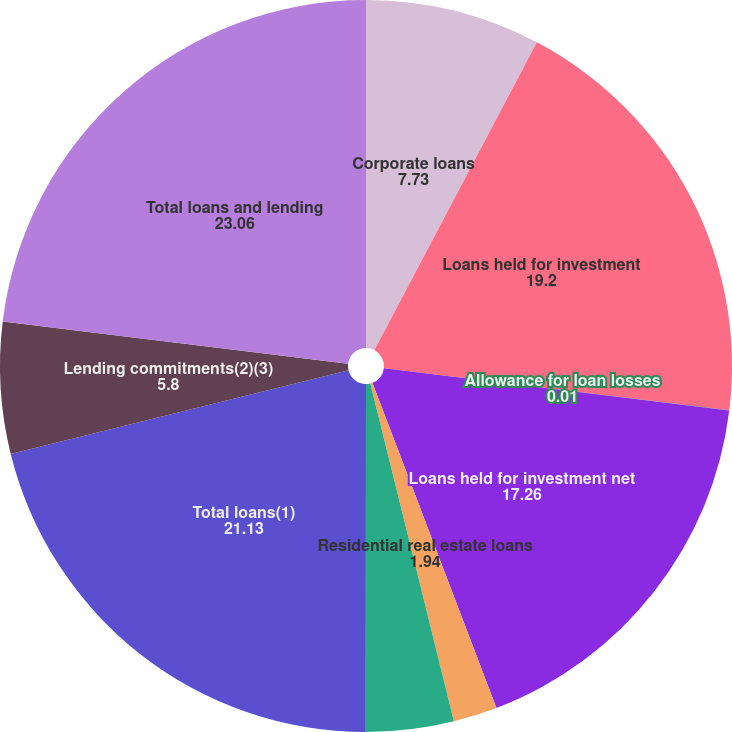<chart> <loc_0><loc_0><loc_500><loc_500><pie_chart><fcel>Corporate loans<fcel>Loans held for investment<fcel>Allowance for loan losses<fcel>Loans held for investment net<fcel>Residential real estate loans<fcel>Loans held for sale<fcel>Total loans(1)<fcel>Lending commitments(2)(3)<fcel>Total loans and lending<nl><fcel>7.73%<fcel>19.2%<fcel>0.01%<fcel>17.26%<fcel>1.94%<fcel>3.87%<fcel>21.13%<fcel>5.8%<fcel>23.06%<nl></chart> 